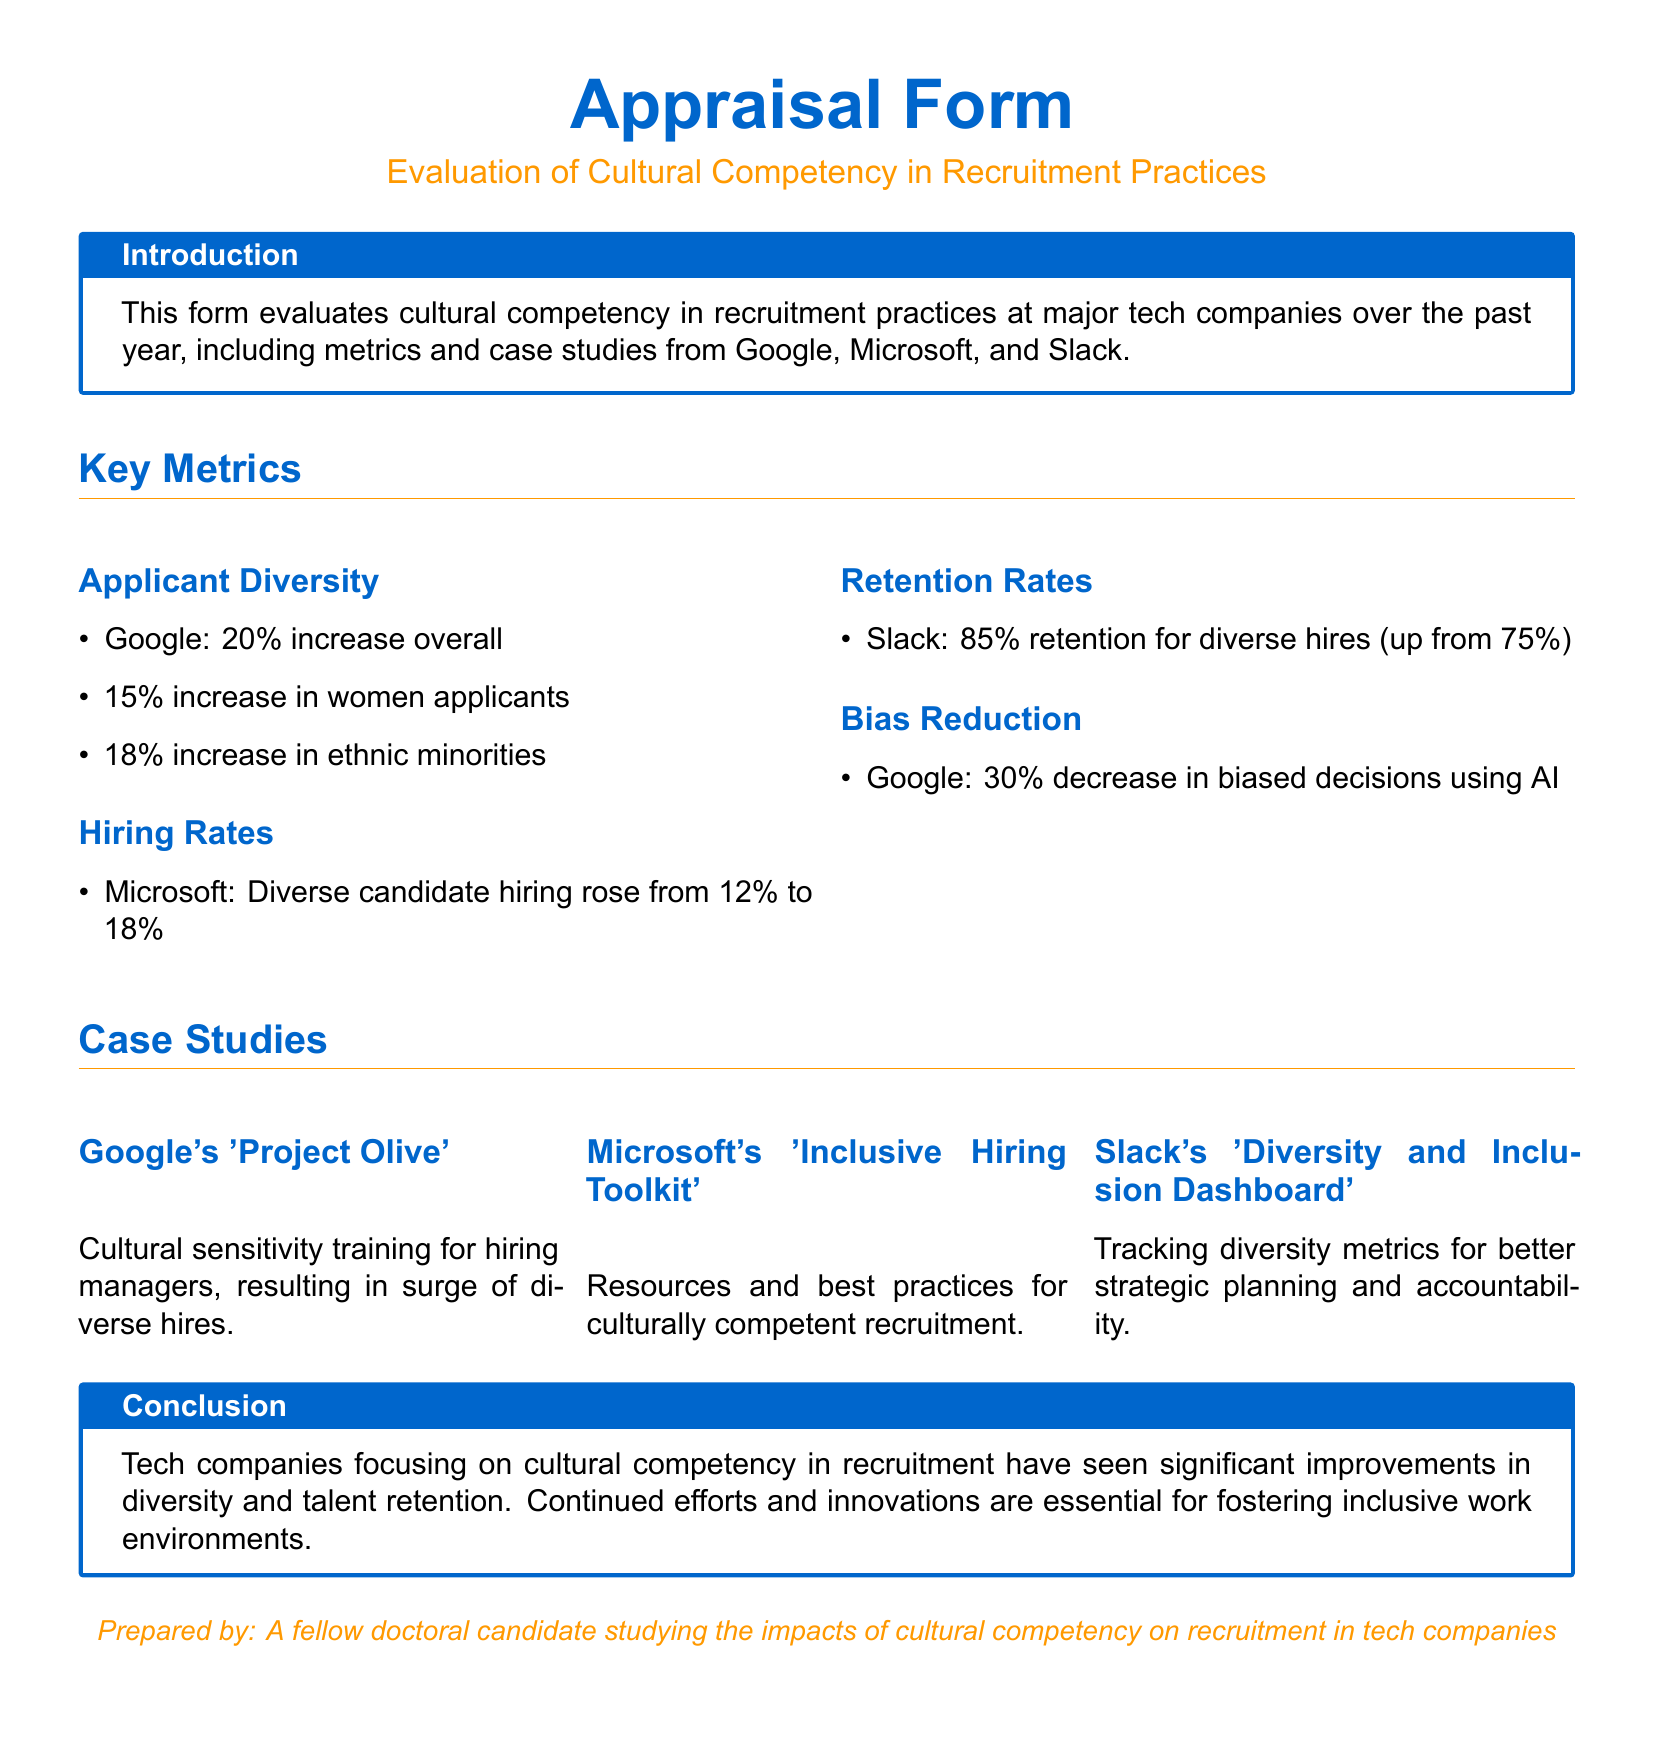What was the overall increase in applicant diversity for Google? The overall increase in applicant diversity is stated as a percentage in the section discussing key metrics for Google.
Answer: 20% What is the retention rate for diverse hires at Slack? The retention rate is mentioned in the retention rates subsection, indicating the percentage of diverse hires retained.
Answer: 85% What tool did Microsoft implement for culturally competent recruitment? The document mentions a specific toolkit aimed at enhancing recruitment processes in a culturally competent manner.
Answer: Inclusive Hiring Toolkit By what percentage did biased decisions decrease at Google? The decrease in biased decisions is provided as a percentage in the bias reduction subsection for Google.
Answer: 30% What kind of training did Google's 'Project Olive' provide? The document specifies the type of training provided to hiring managers through this project aimed at improving cultural sensitivity.
Answer: Cultural sensitivity training What was the increase in women applicants at Google? The document includes a specific percentage increase related to women applicants in the applicant diversity metrics section.
Answer: 15% Which company saw a rise in diverse candidate hiring from 12% to 18%? The company associated with this increase in diverse candidate hiring is explicitly mentioned in the hiring rates section.
Answer: Microsoft What is the purpose of Slack's 'Diversity and Inclusion Dashboard'? The document describes the primary purpose of this dashboard in the context of tracking metrics for strategic planning.
Answer: Tracking diversity metrics How many case studies are mentioned in the document? The number of case studies provided is specified in the case studies section of the appraisal form.
Answer: Three 